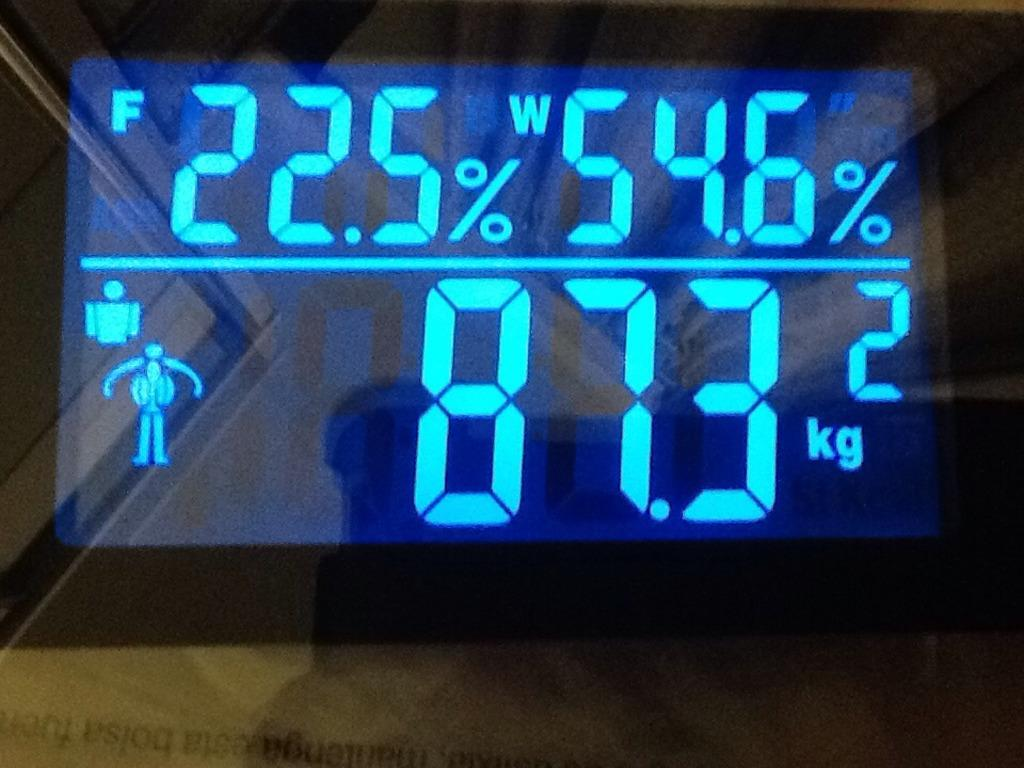<image>
Provide a brief description of the given image. A digital display says 22.5% and 54.6% and includes a little diagram of a person. 